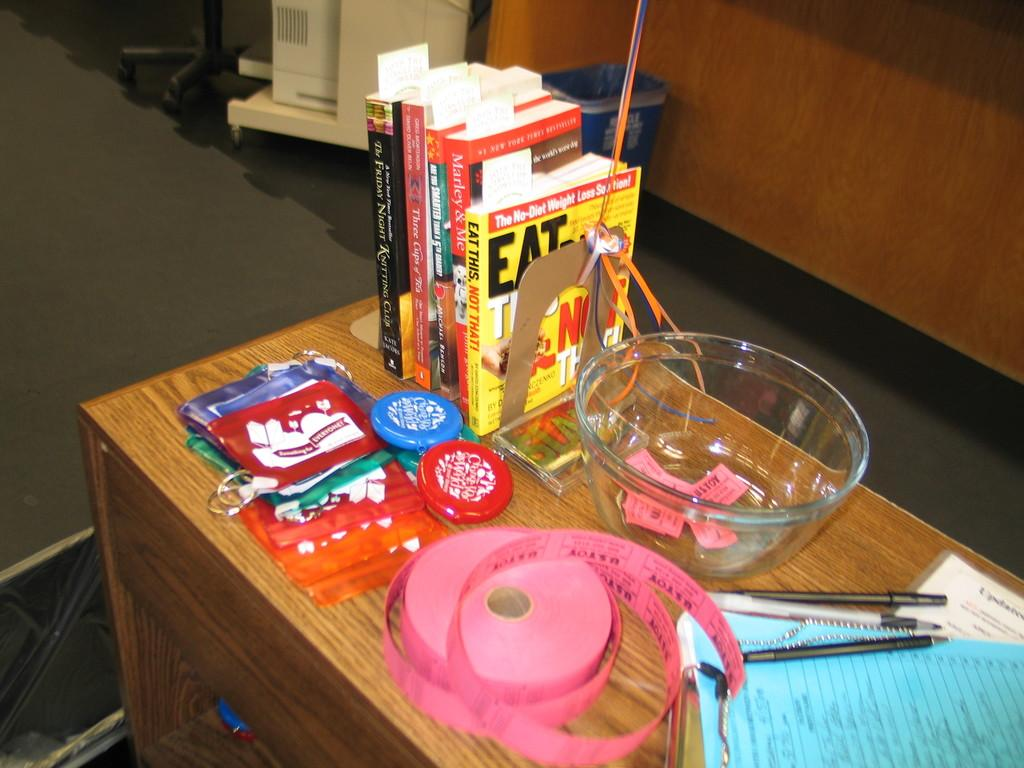Provide a one-sentence caption for the provided image. a counter with tickets, coin holders, and books, one is entitled Eat This Not That. 